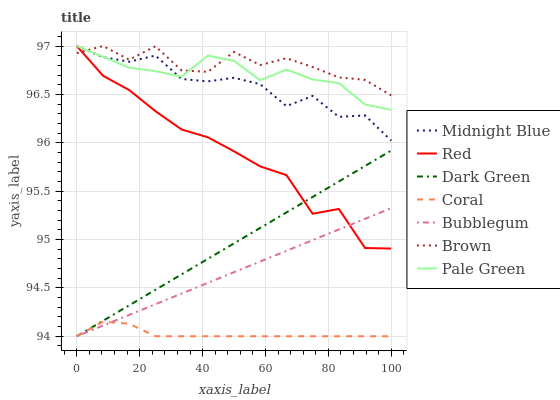Does Coral have the minimum area under the curve?
Answer yes or no. Yes. Does Brown have the maximum area under the curve?
Answer yes or no. Yes. Does Midnight Blue have the minimum area under the curve?
Answer yes or no. No. Does Midnight Blue have the maximum area under the curve?
Answer yes or no. No. Is Bubblegum the smoothest?
Answer yes or no. Yes. Is Brown the roughest?
Answer yes or no. Yes. Is Midnight Blue the smoothest?
Answer yes or no. No. Is Midnight Blue the roughest?
Answer yes or no. No. Does Coral have the lowest value?
Answer yes or no. Yes. Does Midnight Blue have the lowest value?
Answer yes or no. No. Does Red have the highest value?
Answer yes or no. Yes. Does Coral have the highest value?
Answer yes or no. No. Is Coral less than Brown?
Answer yes or no. Yes. Is Red greater than Coral?
Answer yes or no. Yes. Does Pale Green intersect Red?
Answer yes or no. Yes. Is Pale Green less than Red?
Answer yes or no. No. Is Pale Green greater than Red?
Answer yes or no. No. Does Coral intersect Brown?
Answer yes or no. No. 